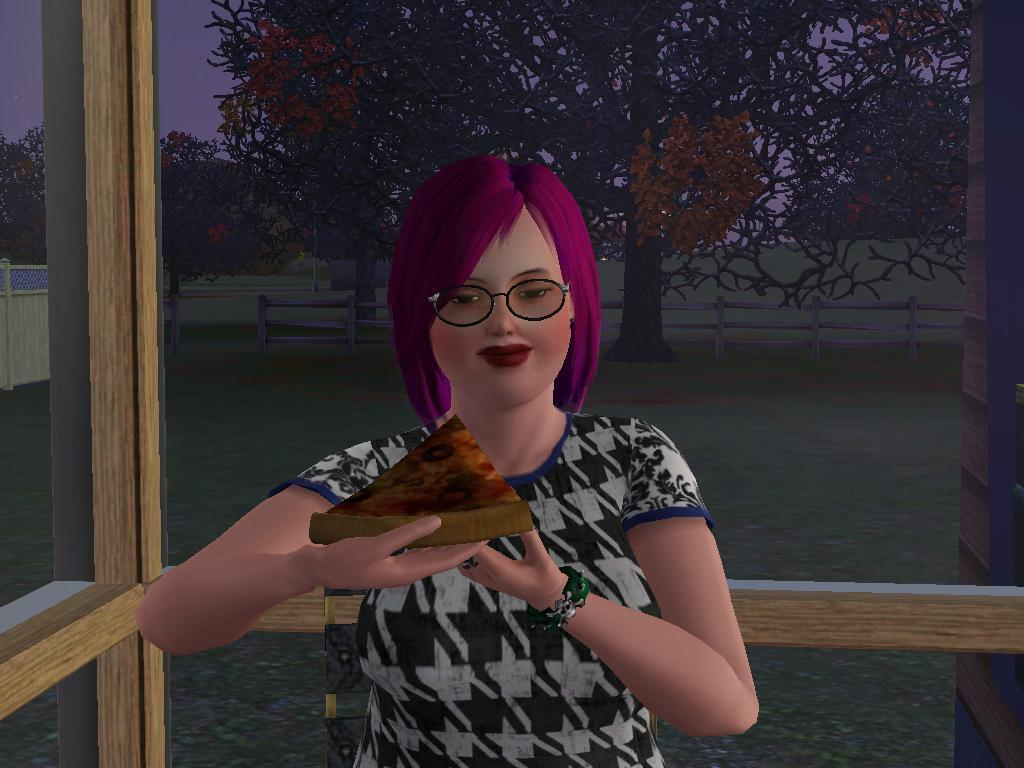What type of image is depicted in the picture? There is an animated image of a woman in the picture. What is the woman holding in the image? The woman is holding a pizza slice. What architectural feature can be seen in the picture? There are windows visible in the picture. What type of vegetation is visible behind the windows? There is a tree behind the windows. What type of beef is being cooked in the image? There is no beef or cooking activity present in the image. What type of rail can be seen in the image? There is no rail present in the image. 